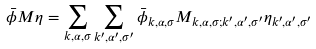<formula> <loc_0><loc_0><loc_500><loc_500>\bar { \phi } M \eta = \sum _ { k , \alpha , \sigma } \sum _ { k ^ { \prime } , \alpha ^ { \prime } , \sigma ^ { \prime } } \bar { \phi } _ { k , \alpha , \sigma } M _ { k , \alpha , \sigma ; k ^ { \prime } , \alpha ^ { \prime } , \sigma ^ { \prime } } \eta _ { k ^ { \prime } , \alpha ^ { \prime } , \sigma ^ { \prime } } \,</formula> 